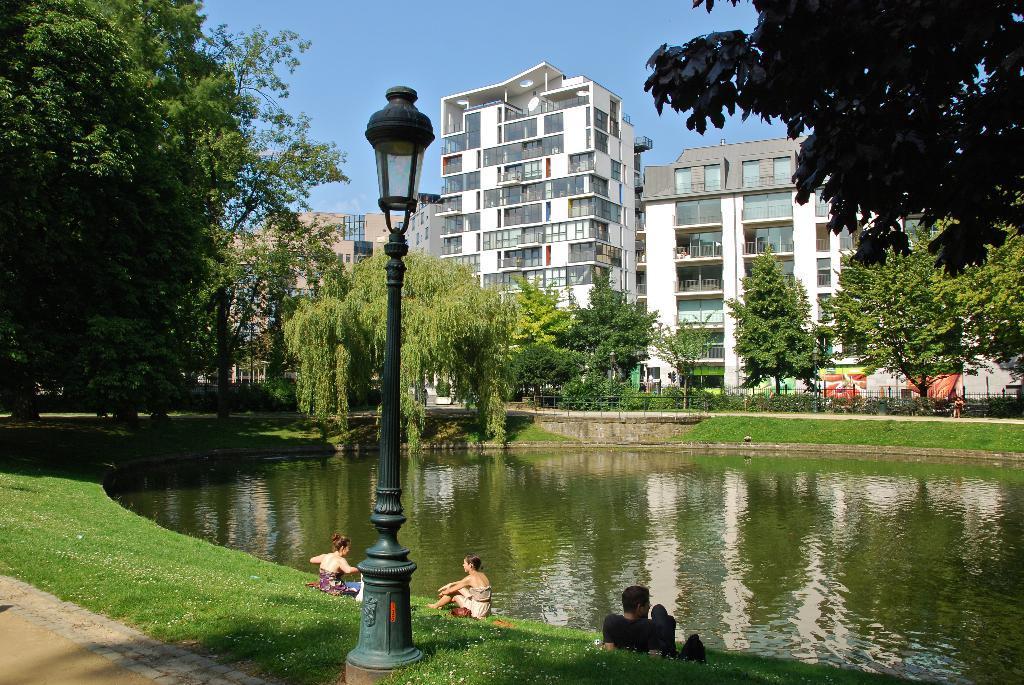Please provide a concise description of this image. In this image I see number of buildings, trees and I see a pole over here and I see the green grass and I see 2 women and a man over here and I see the water and I see the blue sky in the background. 